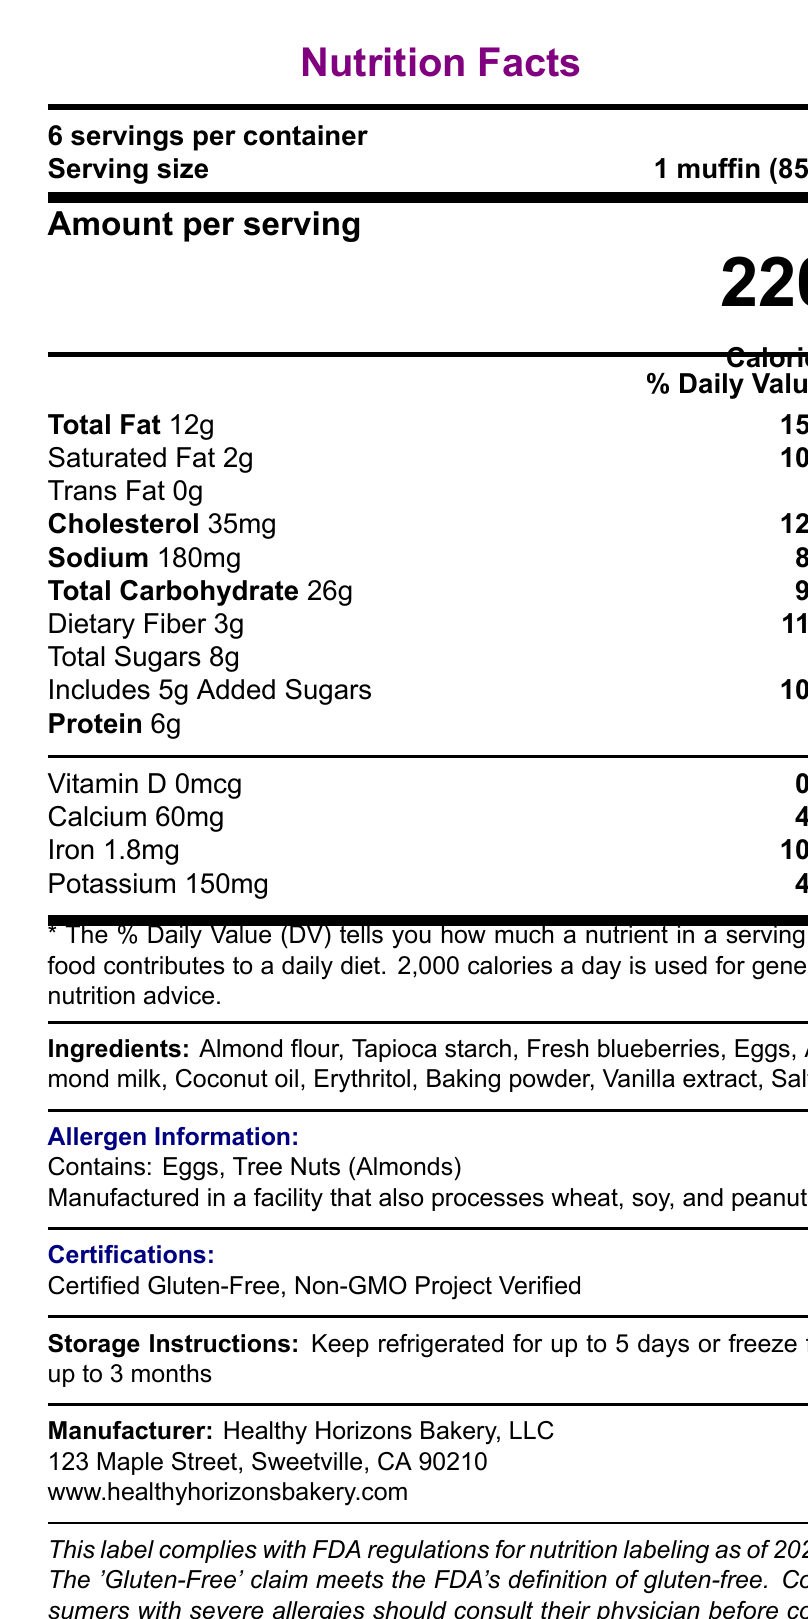what is the serving size of the Gluten-Free Almond Blueberry Muffin? The serving size is clearly listed as "1 muffin (85g)" near the top of the Nutrition Facts label.
Answer: 1 muffin (85g) how many calories are in one serving? The document states "Calories 220" under the "Amount per serving" section.
Answer: 220 what is the total fat content per serving? The "Total Fat" content is listed as 12g under the nutrient details.
Answer: 12g how much dietary fiber does one serving contain? The amount of dietary fiber per serving is given as "Dietary Fiber 3g".
Answer: 3g how much calcium is in one serving? The calcium content is shown as "Calcium 60mg" with a 4% Daily Value.
Answer: 60mg what are the main allergens present in this product? The allergen information section states "Contains: Eggs, Tree Nuts (Almonds)".
Answer: Eggs, Tree Nuts (Almonds) how long can the product be kept refrigerated? The storage instructions specify to "Keep refrigerated for up to 5 days".
Answer: Up to 5 days what is the sodium content per serving? The sodium content is listed as "Sodium 180mg" with an 8% Daily Value.
Answer: 180mg what certifications does the Gluten-Free Almond Blueberry Muffin have? The certifications listed are "Certified Gluten-Free" and "Non-GMO Project Verified".
Answer: Certified Gluten-Free, Non-GMO Project Verified how much iron is in one serving? A. 1mg B. 1.2mg C. 1.5mg D. 1.8mg The iron content per serving is shown as "Iron 1.8mg".
Answer: D. 1.8mg how many grams of saturated fat are in one serving? A. 1g B. 2g C. 3g D. 4g The saturated fat content is listed as "Saturated Fat 2g".
Answer: B. 2g is trans fat present in this product? The document specifies "Trans Fat 0g", indicating that there is no trans fat.
Answer: No are these muffins certified organic? The legal considerations state that the muffins are not certified organic but are Non-GMO.
Answer: No does this product meet FDA regulations for gluten-free labeling? The legal considerations confirm that the gluten-free claim meets the FDA's definition.
Answer: Yes can you determine if this product is vegan based on the label? The label does not provide sufficient details to determine if the product is vegan.
Answer: Not enough information what is the recommended storage method for this product? The storage instructions provide the recommended methods for maintaining the product's freshness.
Answer: Keep refrigerated for up to 5 days or freeze for up to 3 months summarize the main points of the document. The summary should mention the main elements like nutritional information, ingredient list, allergen information, storage instructions, FDA compliance, and manufacturer details.
Answer: This document provides the Nutrition Facts of the "Gluten-Free Almond Blueberry Muffin", including serving size, calorie content, and detailed nutrient information. It lists ingredients, allergen information, storage instructions, certifications, and manufacturer details. The document also notes compliance with FDA regulations and various legal considerations related to labeling and claims. 